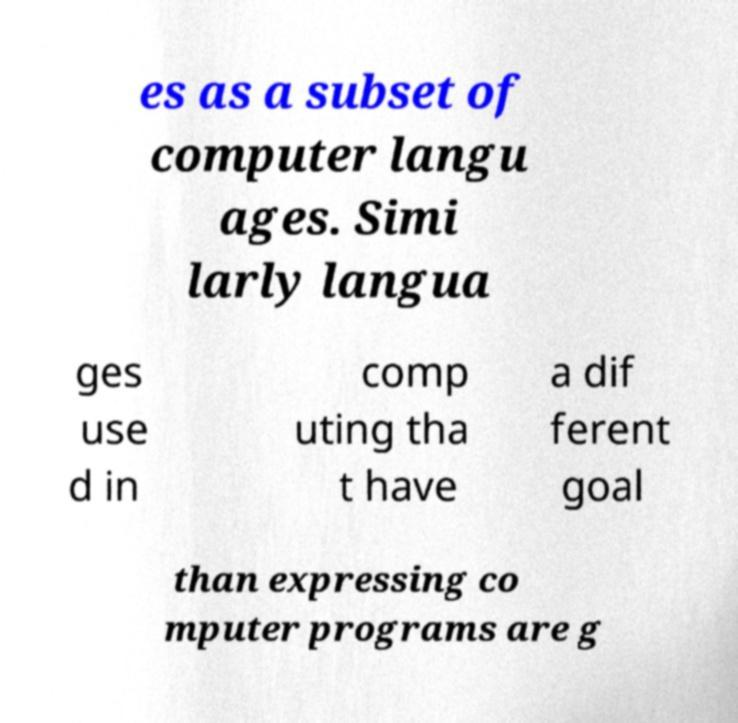Could you assist in decoding the text presented in this image and type it out clearly? es as a subset of computer langu ages. Simi larly langua ges use d in comp uting tha t have a dif ferent goal than expressing co mputer programs are g 